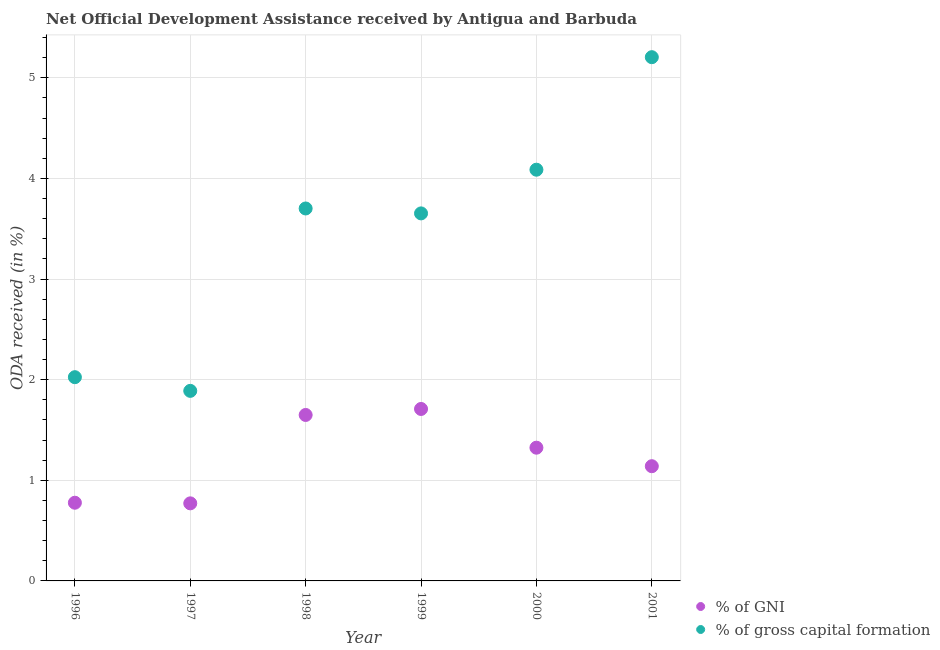Is the number of dotlines equal to the number of legend labels?
Make the answer very short. Yes. What is the oda received as percentage of gross capital formation in 1997?
Your response must be concise. 1.89. Across all years, what is the maximum oda received as percentage of gross capital formation?
Make the answer very short. 5.21. Across all years, what is the minimum oda received as percentage of gni?
Offer a terse response. 0.77. What is the total oda received as percentage of gross capital formation in the graph?
Your answer should be very brief. 20.56. What is the difference between the oda received as percentage of gross capital formation in 2000 and that in 2001?
Your answer should be very brief. -1.12. What is the difference between the oda received as percentage of gni in 1999 and the oda received as percentage of gross capital formation in 2000?
Your answer should be compact. -2.38. What is the average oda received as percentage of gni per year?
Your response must be concise. 1.23. In the year 1996, what is the difference between the oda received as percentage of gross capital formation and oda received as percentage of gni?
Ensure brevity in your answer.  1.25. In how many years, is the oda received as percentage of gni greater than 2.8 %?
Give a very brief answer. 0. What is the ratio of the oda received as percentage of gni in 1996 to that in 2000?
Provide a succinct answer. 0.59. Is the oda received as percentage of gni in 1999 less than that in 2001?
Provide a succinct answer. No. Is the difference between the oda received as percentage of gross capital formation in 1996 and 2000 greater than the difference between the oda received as percentage of gni in 1996 and 2000?
Your answer should be very brief. No. What is the difference between the highest and the second highest oda received as percentage of gni?
Offer a very short reply. 0.06. What is the difference between the highest and the lowest oda received as percentage of gni?
Provide a succinct answer. 0.94. In how many years, is the oda received as percentage of gni greater than the average oda received as percentage of gni taken over all years?
Provide a short and direct response. 3. Does the oda received as percentage of gni monotonically increase over the years?
Your answer should be very brief. No. How many dotlines are there?
Offer a terse response. 2. How many years are there in the graph?
Your response must be concise. 6. Does the graph contain any zero values?
Make the answer very short. No. How many legend labels are there?
Provide a short and direct response. 2. How are the legend labels stacked?
Make the answer very short. Vertical. What is the title of the graph?
Keep it short and to the point. Net Official Development Assistance received by Antigua and Barbuda. Does "Exports of goods" appear as one of the legend labels in the graph?
Offer a terse response. No. What is the label or title of the X-axis?
Offer a terse response. Year. What is the label or title of the Y-axis?
Offer a terse response. ODA received (in %). What is the ODA received (in %) in % of GNI in 1996?
Offer a very short reply. 0.78. What is the ODA received (in %) in % of gross capital formation in 1996?
Keep it short and to the point. 2.02. What is the ODA received (in %) in % of GNI in 1997?
Give a very brief answer. 0.77. What is the ODA received (in %) of % of gross capital formation in 1997?
Offer a terse response. 1.89. What is the ODA received (in %) in % of GNI in 1998?
Keep it short and to the point. 1.65. What is the ODA received (in %) in % of gross capital formation in 1998?
Ensure brevity in your answer.  3.7. What is the ODA received (in %) in % of GNI in 1999?
Keep it short and to the point. 1.71. What is the ODA received (in %) of % of gross capital formation in 1999?
Offer a very short reply. 3.65. What is the ODA received (in %) in % of GNI in 2000?
Your answer should be compact. 1.32. What is the ODA received (in %) in % of gross capital formation in 2000?
Make the answer very short. 4.09. What is the ODA received (in %) of % of GNI in 2001?
Give a very brief answer. 1.14. What is the ODA received (in %) of % of gross capital formation in 2001?
Your response must be concise. 5.21. Across all years, what is the maximum ODA received (in %) in % of GNI?
Your answer should be compact. 1.71. Across all years, what is the maximum ODA received (in %) of % of gross capital formation?
Ensure brevity in your answer.  5.21. Across all years, what is the minimum ODA received (in %) of % of GNI?
Offer a very short reply. 0.77. Across all years, what is the minimum ODA received (in %) in % of gross capital formation?
Provide a short and direct response. 1.89. What is the total ODA received (in %) of % of GNI in the graph?
Make the answer very short. 7.37. What is the total ODA received (in %) of % of gross capital formation in the graph?
Ensure brevity in your answer.  20.56. What is the difference between the ODA received (in %) in % of GNI in 1996 and that in 1997?
Give a very brief answer. 0.01. What is the difference between the ODA received (in %) of % of gross capital formation in 1996 and that in 1997?
Keep it short and to the point. 0.14. What is the difference between the ODA received (in %) of % of GNI in 1996 and that in 1998?
Your answer should be compact. -0.87. What is the difference between the ODA received (in %) in % of gross capital formation in 1996 and that in 1998?
Offer a terse response. -1.68. What is the difference between the ODA received (in %) of % of GNI in 1996 and that in 1999?
Give a very brief answer. -0.93. What is the difference between the ODA received (in %) of % of gross capital formation in 1996 and that in 1999?
Your response must be concise. -1.63. What is the difference between the ODA received (in %) in % of GNI in 1996 and that in 2000?
Your answer should be very brief. -0.55. What is the difference between the ODA received (in %) in % of gross capital formation in 1996 and that in 2000?
Provide a short and direct response. -2.06. What is the difference between the ODA received (in %) in % of GNI in 1996 and that in 2001?
Make the answer very short. -0.36. What is the difference between the ODA received (in %) of % of gross capital formation in 1996 and that in 2001?
Your answer should be compact. -3.18. What is the difference between the ODA received (in %) of % of GNI in 1997 and that in 1998?
Give a very brief answer. -0.88. What is the difference between the ODA received (in %) of % of gross capital formation in 1997 and that in 1998?
Your answer should be very brief. -1.81. What is the difference between the ODA received (in %) of % of GNI in 1997 and that in 1999?
Give a very brief answer. -0.94. What is the difference between the ODA received (in %) in % of gross capital formation in 1997 and that in 1999?
Give a very brief answer. -1.76. What is the difference between the ODA received (in %) of % of GNI in 1997 and that in 2000?
Ensure brevity in your answer.  -0.55. What is the difference between the ODA received (in %) in % of gross capital formation in 1997 and that in 2000?
Ensure brevity in your answer.  -2.2. What is the difference between the ODA received (in %) of % of GNI in 1997 and that in 2001?
Provide a succinct answer. -0.37. What is the difference between the ODA received (in %) of % of gross capital formation in 1997 and that in 2001?
Give a very brief answer. -3.32. What is the difference between the ODA received (in %) of % of GNI in 1998 and that in 1999?
Keep it short and to the point. -0.06. What is the difference between the ODA received (in %) of % of gross capital formation in 1998 and that in 1999?
Offer a terse response. 0.05. What is the difference between the ODA received (in %) of % of GNI in 1998 and that in 2000?
Ensure brevity in your answer.  0.33. What is the difference between the ODA received (in %) of % of gross capital formation in 1998 and that in 2000?
Provide a succinct answer. -0.39. What is the difference between the ODA received (in %) in % of GNI in 1998 and that in 2001?
Offer a very short reply. 0.51. What is the difference between the ODA received (in %) in % of gross capital formation in 1998 and that in 2001?
Your response must be concise. -1.5. What is the difference between the ODA received (in %) of % of GNI in 1999 and that in 2000?
Offer a very short reply. 0.38. What is the difference between the ODA received (in %) of % of gross capital formation in 1999 and that in 2000?
Offer a very short reply. -0.43. What is the difference between the ODA received (in %) of % of GNI in 1999 and that in 2001?
Make the answer very short. 0.57. What is the difference between the ODA received (in %) of % of gross capital formation in 1999 and that in 2001?
Give a very brief answer. -1.55. What is the difference between the ODA received (in %) in % of GNI in 2000 and that in 2001?
Offer a very short reply. 0.18. What is the difference between the ODA received (in %) in % of gross capital formation in 2000 and that in 2001?
Ensure brevity in your answer.  -1.12. What is the difference between the ODA received (in %) in % of GNI in 1996 and the ODA received (in %) in % of gross capital formation in 1997?
Your answer should be compact. -1.11. What is the difference between the ODA received (in %) of % of GNI in 1996 and the ODA received (in %) of % of gross capital formation in 1998?
Give a very brief answer. -2.92. What is the difference between the ODA received (in %) of % of GNI in 1996 and the ODA received (in %) of % of gross capital formation in 1999?
Your answer should be compact. -2.88. What is the difference between the ODA received (in %) in % of GNI in 1996 and the ODA received (in %) in % of gross capital formation in 2000?
Give a very brief answer. -3.31. What is the difference between the ODA received (in %) in % of GNI in 1996 and the ODA received (in %) in % of gross capital formation in 2001?
Ensure brevity in your answer.  -4.43. What is the difference between the ODA received (in %) in % of GNI in 1997 and the ODA received (in %) in % of gross capital formation in 1998?
Offer a very short reply. -2.93. What is the difference between the ODA received (in %) in % of GNI in 1997 and the ODA received (in %) in % of gross capital formation in 1999?
Offer a very short reply. -2.88. What is the difference between the ODA received (in %) in % of GNI in 1997 and the ODA received (in %) in % of gross capital formation in 2000?
Give a very brief answer. -3.32. What is the difference between the ODA received (in %) in % of GNI in 1997 and the ODA received (in %) in % of gross capital formation in 2001?
Offer a terse response. -4.43. What is the difference between the ODA received (in %) in % of GNI in 1998 and the ODA received (in %) in % of gross capital formation in 1999?
Make the answer very short. -2. What is the difference between the ODA received (in %) in % of GNI in 1998 and the ODA received (in %) in % of gross capital formation in 2000?
Your answer should be very brief. -2.44. What is the difference between the ODA received (in %) of % of GNI in 1998 and the ODA received (in %) of % of gross capital formation in 2001?
Keep it short and to the point. -3.56. What is the difference between the ODA received (in %) of % of GNI in 1999 and the ODA received (in %) of % of gross capital formation in 2000?
Your answer should be compact. -2.38. What is the difference between the ODA received (in %) in % of GNI in 1999 and the ODA received (in %) in % of gross capital formation in 2001?
Keep it short and to the point. -3.5. What is the difference between the ODA received (in %) of % of GNI in 2000 and the ODA received (in %) of % of gross capital formation in 2001?
Provide a short and direct response. -3.88. What is the average ODA received (in %) of % of GNI per year?
Your answer should be compact. 1.23. What is the average ODA received (in %) of % of gross capital formation per year?
Make the answer very short. 3.43. In the year 1996, what is the difference between the ODA received (in %) in % of GNI and ODA received (in %) in % of gross capital formation?
Make the answer very short. -1.25. In the year 1997, what is the difference between the ODA received (in %) of % of GNI and ODA received (in %) of % of gross capital formation?
Your answer should be very brief. -1.12. In the year 1998, what is the difference between the ODA received (in %) of % of GNI and ODA received (in %) of % of gross capital formation?
Offer a very short reply. -2.05. In the year 1999, what is the difference between the ODA received (in %) in % of GNI and ODA received (in %) in % of gross capital formation?
Offer a very short reply. -1.94. In the year 2000, what is the difference between the ODA received (in %) of % of GNI and ODA received (in %) of % of gross capital formation?
Ensure brevity in your answer.  -2.76. In the year 2001, what is the difference between the ODA received (in %) in % of GNI and ODA received (in %) in % of gross capital formation?
Offer a terse response. -4.07. What is the ratio of the ODA received (in %) in % of GNI in 1996 to that in 1997?
Make the answer very short. 1.01. What is the ratio of the ODA received (in %) in % of gross capital formation in 1996 to that in 1997?
Make the answer very short. 1.07. What is the ratio of the ODA received (in %) in % of GNI in 1996 to that in 1998?
Keep it short and to the point. 0.47. What is the ratio of the ODA received (in %) in % of gross capital formation in 1996 to that in 1998?
Provide a succinct answer. 0.55. What is the ratio of the ODA received (in %) of % of GNI in 1996 to that in 1999?
Ensure brevity in your answer.  0.45. What is the ratio of the ODA received (in %) of % of gross capital formation in 1996 to that in 1999?
Give a very brief answer. 0.55. What is the ratio of the ODA received (in %) in % of GNI in 1996 to that in 2000?
Your response must be concise. 0.59. What is the ratio of the ODA received (in %) in % of gross capital formation in 1996 to that in 2000?
Offer a very short reply. 0.5. What is the ratio of the ODA received (in %) of % of GNI in 1996 to that in 2001?
Provide a short and direct response. 0.68. What is the ratio of the ODA received (in %) of % of gross capital formation in 1996 to that in 2001?
Give a very brief answer. 0.39. What is the ratio of the ODA received (in %) of % of GNI in 1997 to that in 1998?
Make the answer very short. 0.47. What is the ratio of the ODA received (in %) in % of gross capital formation in 1997 to that in 1998?
Your answer should be very brief. 0.51. What is the ratio of the ODA received (in %) in % of GNI in 1997 to that in 1999?
Give a very brief answer. 0.45. What is the ratio of the ODA received (in %) in % of gross capital formation in 1997 to that in 1999?
Your response must be concise. 0.52. What is the ratio of the ODA received (in %) in % of GNI in 1997 to that in 2000?
Make the answer very short. 0.58. What is the ratio of the ODA received (in %) of % of gross capital formation in 1997 to that in 2000?
Provide a succinct answer. 0.46. What is the ratio of the ODA received (in %) in % of GNI in 1997 to that in 2001?
Offer a very short reply. 0.68. What is the ratio of the ODA received (in %) of % of gross capital formation in 1997 to that in 2001?
Offer a terse response. 0.36. What is the ratio of the ODA received (in %) in % of GNI in 1998 to that in 1999?
Ensure brevity in your answer.  0.97. What is the ratio of the ODA received (in %) of % of gross capital formation in 1998 to that in 1999?
Make the answer very short. 1.01. What is the ratio of the ODA received (in %) in % of GNI in 1998 to that in 2000?
Your response must be concise. 1.25. What is the ratio of the ODA received (in %) in % of gross capital formation in 1998 to that in 2000?
Your answer should be compact. 0.91. What is the ratio of the ODA received (in %) of % of GNI in 1998 to that in 2001?
Provide a succinct answer. 1.45. What is the ratio of the ODA received (in %) in % of gross capital formation in 1998 to that in 2001?
Your response must be concise. 0.71. What is the ratio of the ODA received (in %) in % of GNI in 1999 to that in 2000?
Your response must be concise. 1.29. What is the ratio of the ODA received (in %) of % of gross capital formation in 1999 to that in 2000?
Make the answer very short. 0.89. What is the ratio of the ODA received (in %) of % of GNI in 1999 to that in 2001?
Your response must be concise. 1.5. What is the ratio of the ODA received (in %) in % of gross capital formation in 1999 to that in 2001?
Give a very brief answer. 0.7. What is the ratio of the ODA received (in %) of % of GNI in 2000 to that in 2001?
Provide a succinct answer. 1.16. What is the ratio of the ODA received (in %) of % of gross capital formation in 2000 to that in 2001?
Provide a succinct answer. 0.79. What is the difference between the highest and the second highest ODA received (in %) of % of GNI?
Provide a succinct answer. 0.06. What is the difference between the highest and the second highest ODA received (in %) of % of gross capital formation?
Your answer should be compact. 1.12. What is the difference between the highest and the lowest ODA received (in %) of % of GNI?
Your answer should be very brief. 0.94. What is the difference between the highest and the lowest ODA received (in %) in % of gross capital formation?
Keep it short and to the point. 3.32. 